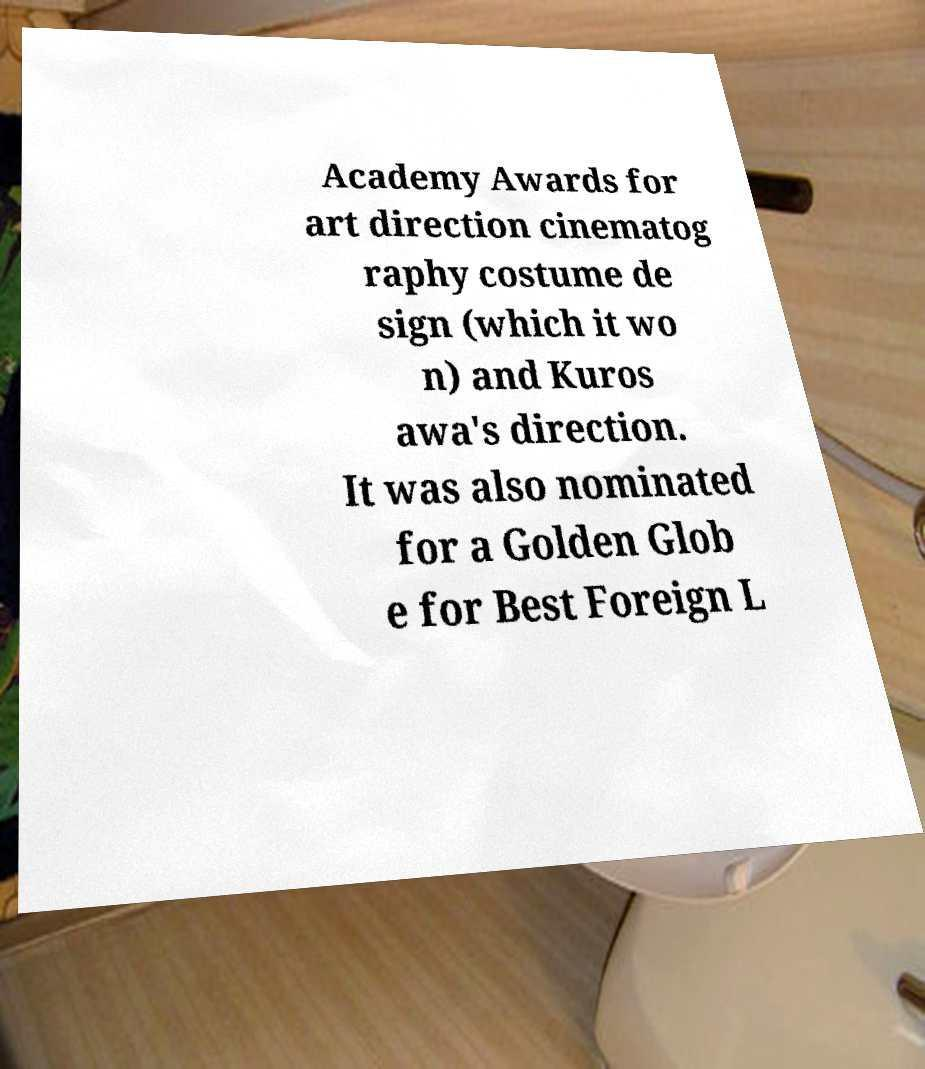Please read and relay the text visible in this image. What does it say? Academy Awards for art direction cinematog raphy costume de sign (which it wo n) and Kuros awa's direction. It was also nominated for a Golden Glob e for Best Foreign L 